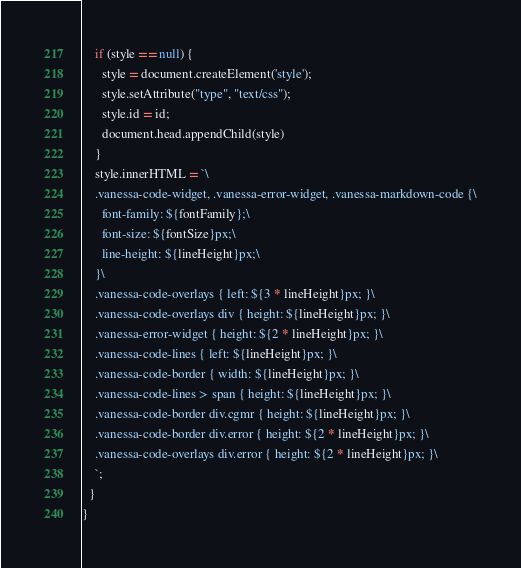Convert code to text. <code><loc_0><loc_0><loc_500><loc_500><_TypeScript_>    if (style == null) {
      style = document.createElement('style');
      style.setAttribute("type", "text/css");
      style.id = id;
      document.head.appendChild(style)
    }
    style.innerHTML = `\
    .vanessa-code-widget, .vanessa-error-widget, .vanessa-markdown-code {\
      font-family: ${fontFamily};\
      font-size: ${fontSize}px;\
      line-height: ${lineHeight}px;\
    }\
    .vanessa-code-overlays { left: ${3 * lineHeight}px; }\
    .vanessa-code-overlays div { height: ${lineHeight}px; }\
    .vanessa-error-widget { height: ${2 * lineHeight}px; }\
    .vanessa-code-lines { left: ${lineHeight}px; }\
    .vanessa-code-border { width: ${lineHeight}px; }\
    .vanessa-code-lines > span { height: ${lineHeight}px; }\
    .vanessa-code-border div.cgmr { height: ${lineHeight}px; }\
    .vanessa-code-border div.error { height: ${2 * lineHeight}px; }\
    .vanessa-code-overlays div.error { height: ${2 * lineHeight}px; }\
    `;
  }
}
</code> 